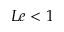<formula> <loc_0><loc_0><loc_500><loc_500>L e < 1</formula> 